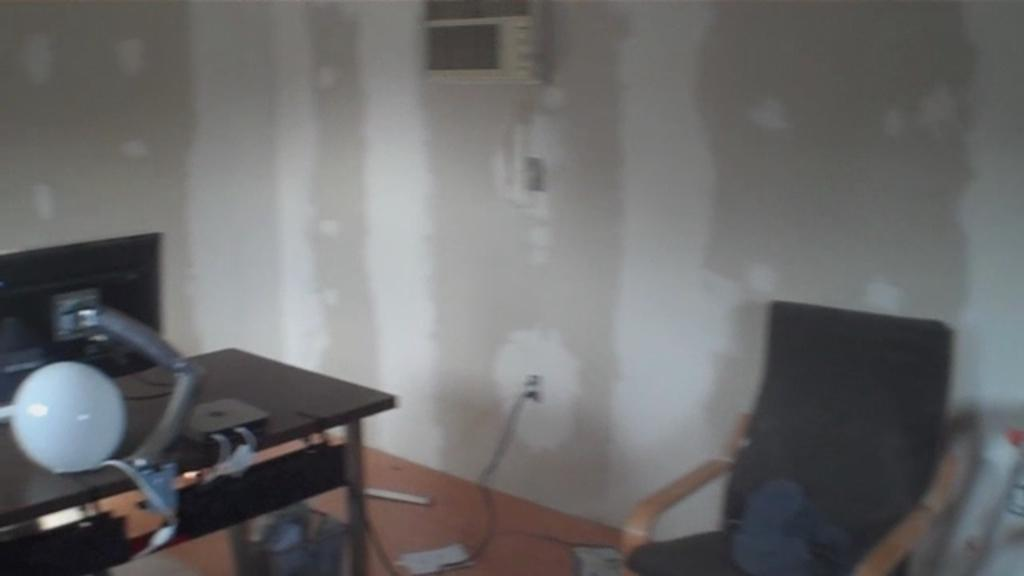What type of furniture is located on the right side of the image? There is a chair on the right side of the image. What type of furniture is located on the left side of the image? There is a table on the left side of the image. What can be seen in the background of the image? There is a wall visible in the background of the image. What type of liquid is flowing down the wall in the image? There is no liquid flowing down the wall in the image; only a wall is visible in the background. 